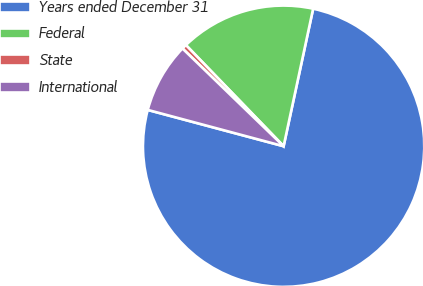<chart> <loc_0><loc_0><loc_500><loc_500><pie_chart><fcel>Years ended December 31<fcel>Federal<fcel>State<fcel>International<nl><fcel>75.79%<fcel>15.59%<fcel>0.55%<fcel>8.07%<nl></chart> 